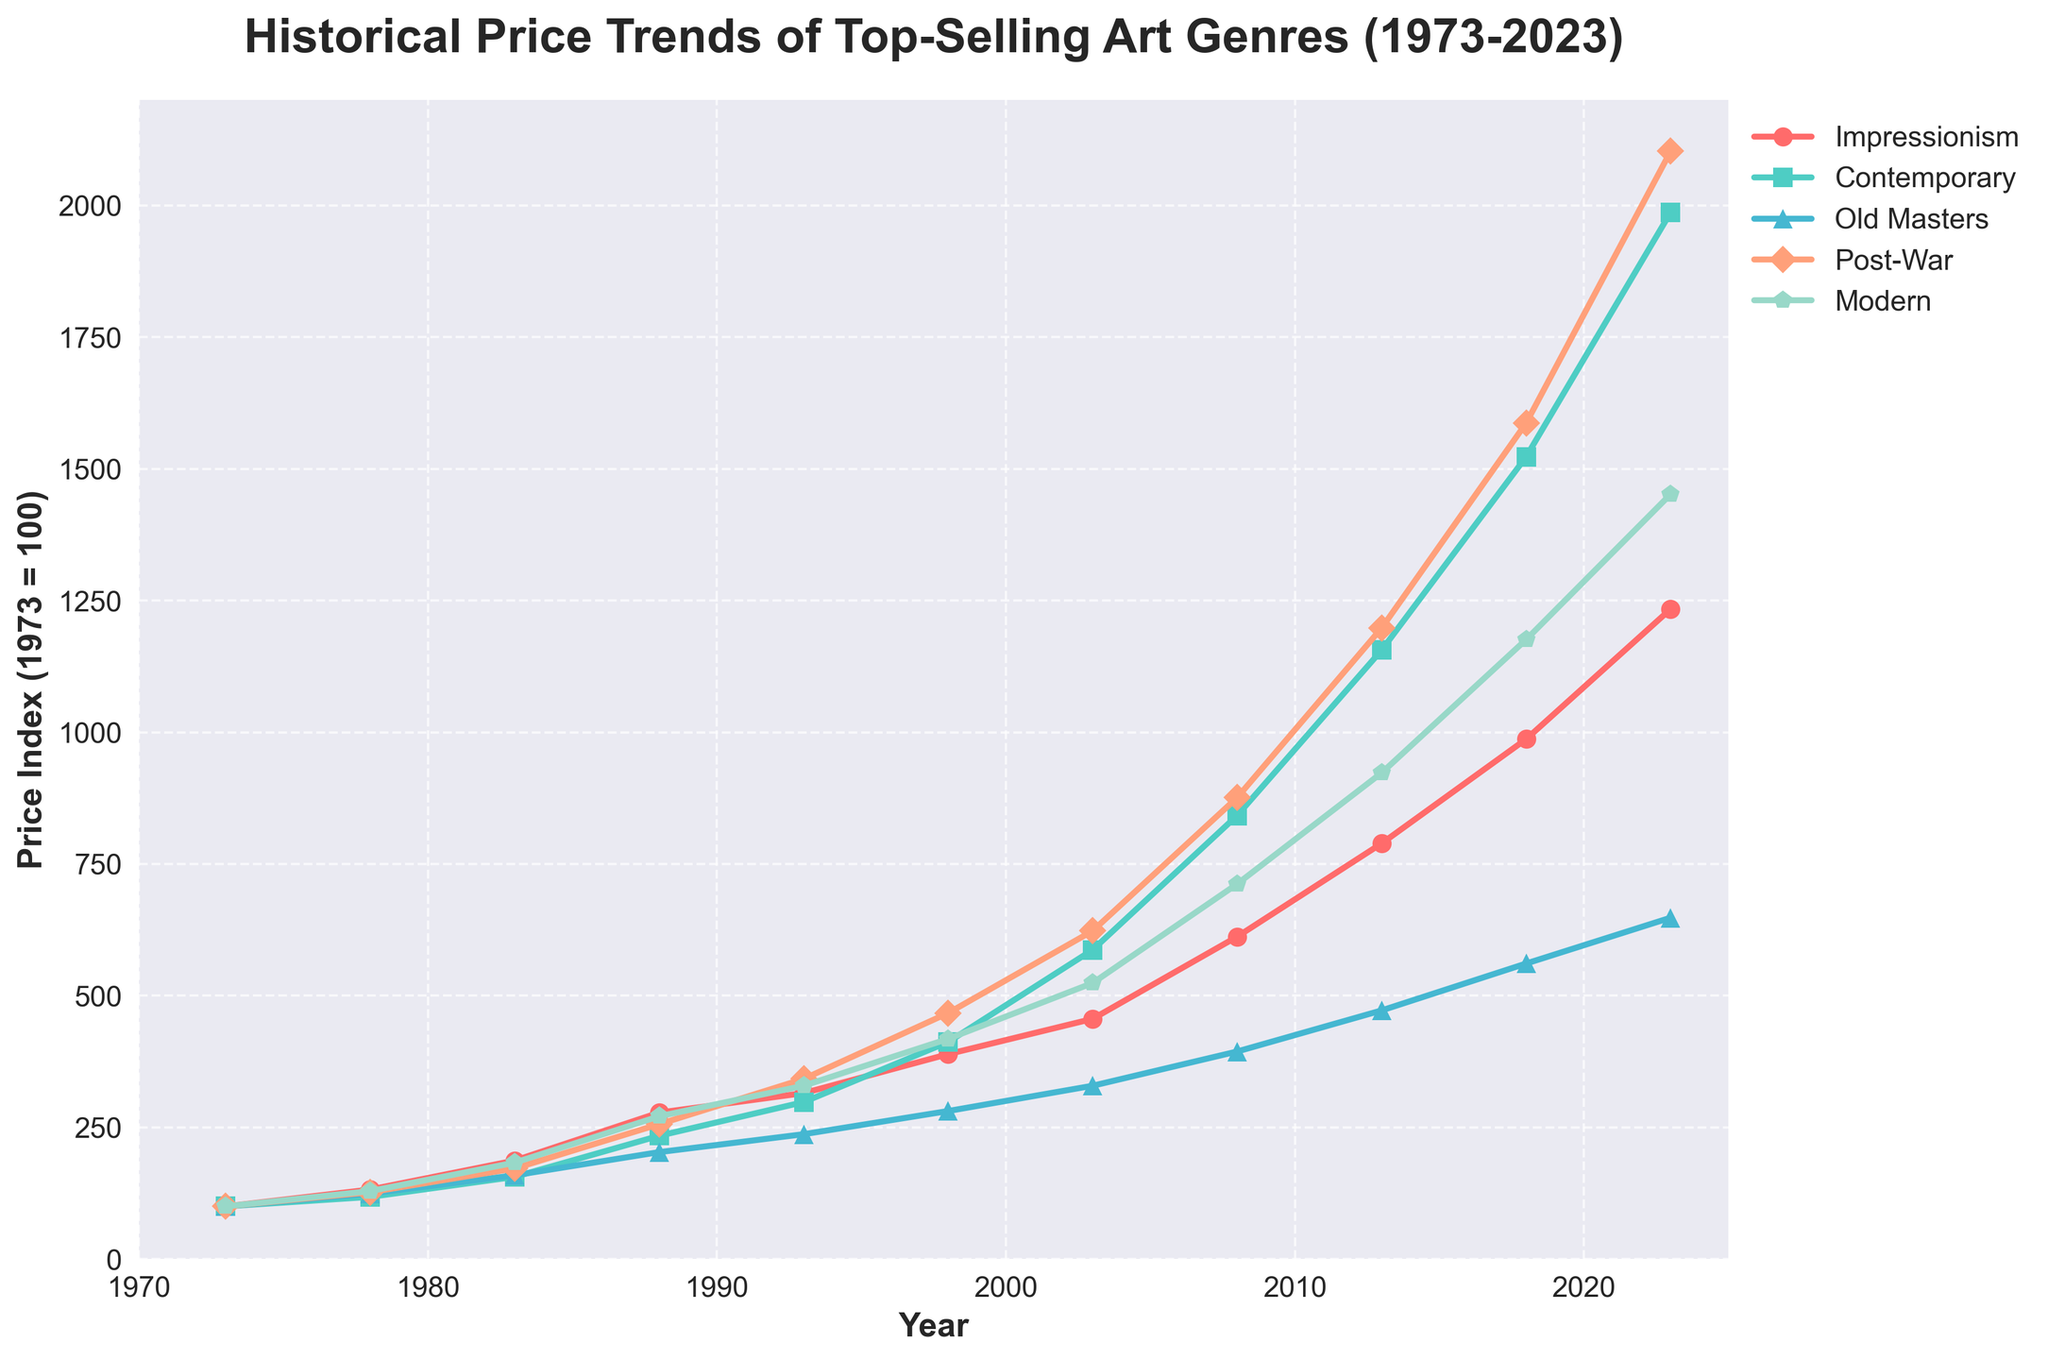Which art genre experienced the highest increase in price index over the 50-year period? Compare the price indices of all art genres in 1973 and 2023. Impressionism increased from 100 to 1234, Contemporary from 100 to 1987, Old Masters from 100 to 648, Post-War from 100 to 2103, and Modern from 100 to 1452. Post-War art shows the highest increase.
Answer: Post-War By how much did the price index for Contemporary art increase between 1973 and 2023? Subtract the price index of Contemporary art in 1973 from the 2023 value (1987 - 100).
Answer: 1887 Which art genre had the lowest price index in 1993? Compare the price indices of all art genres in 1993. Impressionism is 315, Contemporary is 298, Old Masters is 237, Post-War is 342, and Modern is 329. The lowest is Old Masters.
Answer: Old Masters Which art genres had a price index greater than 1000 in 2018? Check the 2018 values for each genre. Impressionism is 987, Contemporary is 1523, Old Masters is 561, Post-War is 1587, and Modern is 1176. Contemporary, Post-War, and Modern are greater than 1000.
Answer: Contemporary, Post-War, Modern What's the average price index of Impressionism and Modern art in 2023? Sum the price indices of Impressionism (1234) and Modern (1452), and then divide by 2. (1234 + 1452) / 2 = 2686 / 2.
Answer: 1343 Which art genre experienced the smallest increase in price index between 1978 and 1983? Compare the differences between 1978 and 1983 for each genre. Impressionism increased by 55 (187-132), Contemporary by 38 (156-118), Old Masters by 35 (159-124), Post-War by 45 (172-127), Modern by 54 (183-129). The smallest increase is for Old Masters.
Answer: Old Masters How does the price index of Old Masters art in 2018 compare to Modern art in 2008? The price index of Old Masters in 2018 is 561 and Modern art in 2008 is 712. 561 is less than 712.
Answer: Less Which art genres had a price index of less than 300 in 1993? Compare the 1993 values: Impressionism is 315, Contemporary is 298, Old Masters is 237, Post-War is 342, Modern is 329. Only Contemporary and Old Masters are under 300.
Answer: Contemporary, Old Masters What is the trend for Contemporary art from 1973 to 2023? Contemporary art shows a continuously increasing trend: 100 (1973), 118 (1978), 156 (1983), 234 (1988), 298 (1993), 412 (1998), 587 (2003), 842 (2008), 1156 (2013), 1523 (2018), 1987 (2023).
Answer: Increasing 